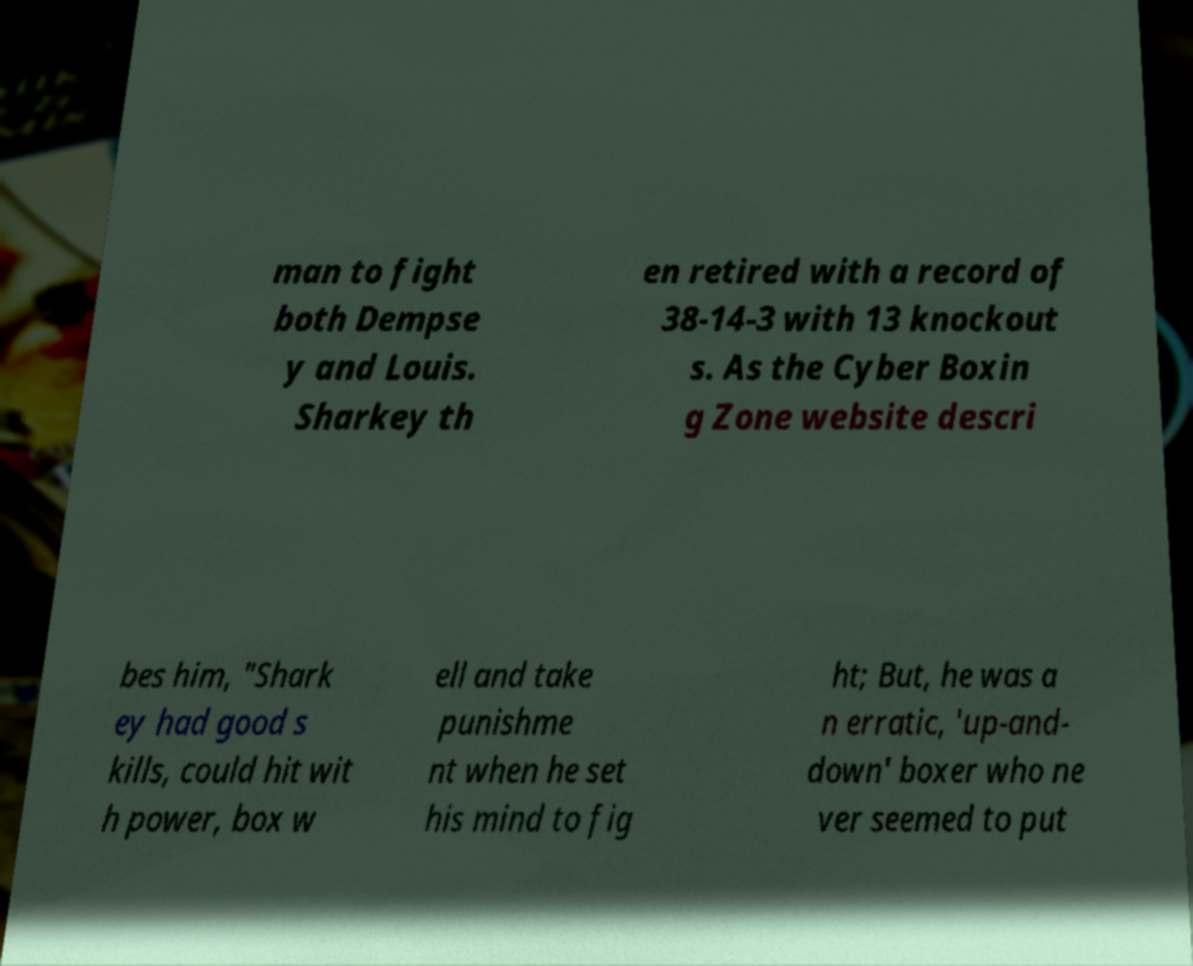There's text embedded in this image that I need extracted. Can you transcribe it verbatim? man to fight both Dempse y and Louis. Sharkey th en retired with a record of 38-14-3 with 13 knockout s. As the Cyber Boxin g Zone website descri bes him, "Shark ey had good s kills, could hit wit h power, box w ell and take punishme nt when he set his mind to fig ht; But, he was a n erratic, 'up-and- down' boxer who ne ver seemed to put 